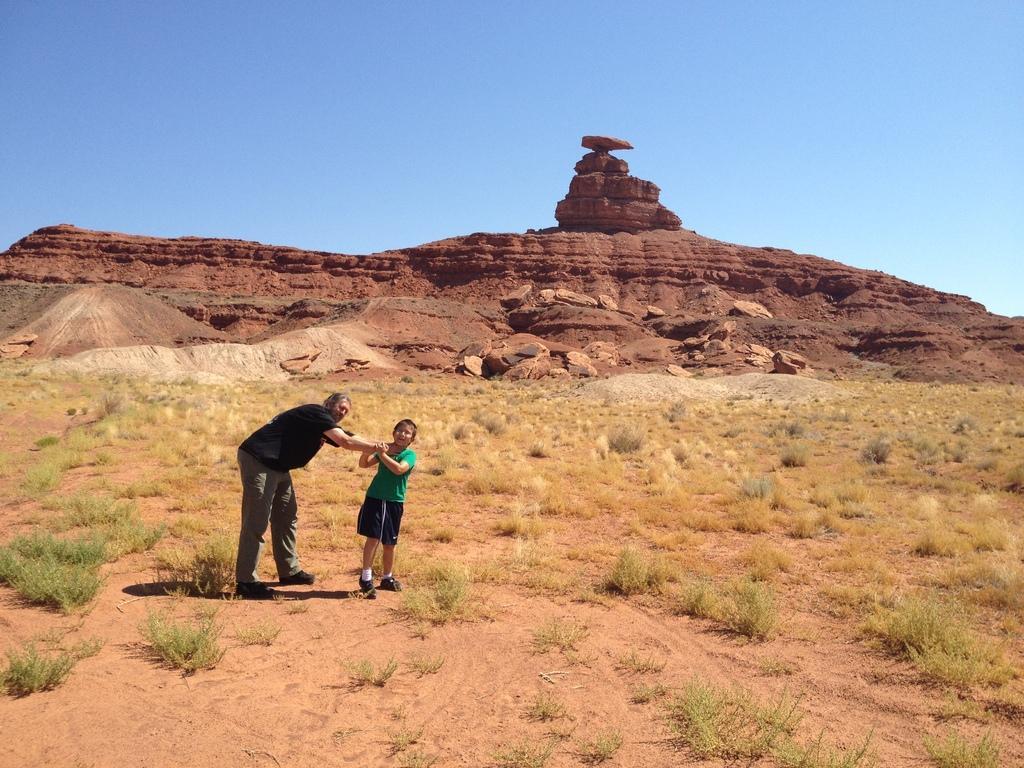Can you describe this image briefly? In this image we can see a man holding the neck of a child. We can also see some grass and the hills. On the backside we can see the sky which looks cloudy. 